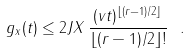<formula> <loc_0><loc_0><loc_500><loc_500>g _ { x } ( t ) \leq 2 J \| X \| \, \frac { ( v t ) ^ { \lfloor ( r - 1 ) / 2 \rfloor } } { \lfloor ( r - 1 ) / 2 \rfloor ! } \ .</formula> 